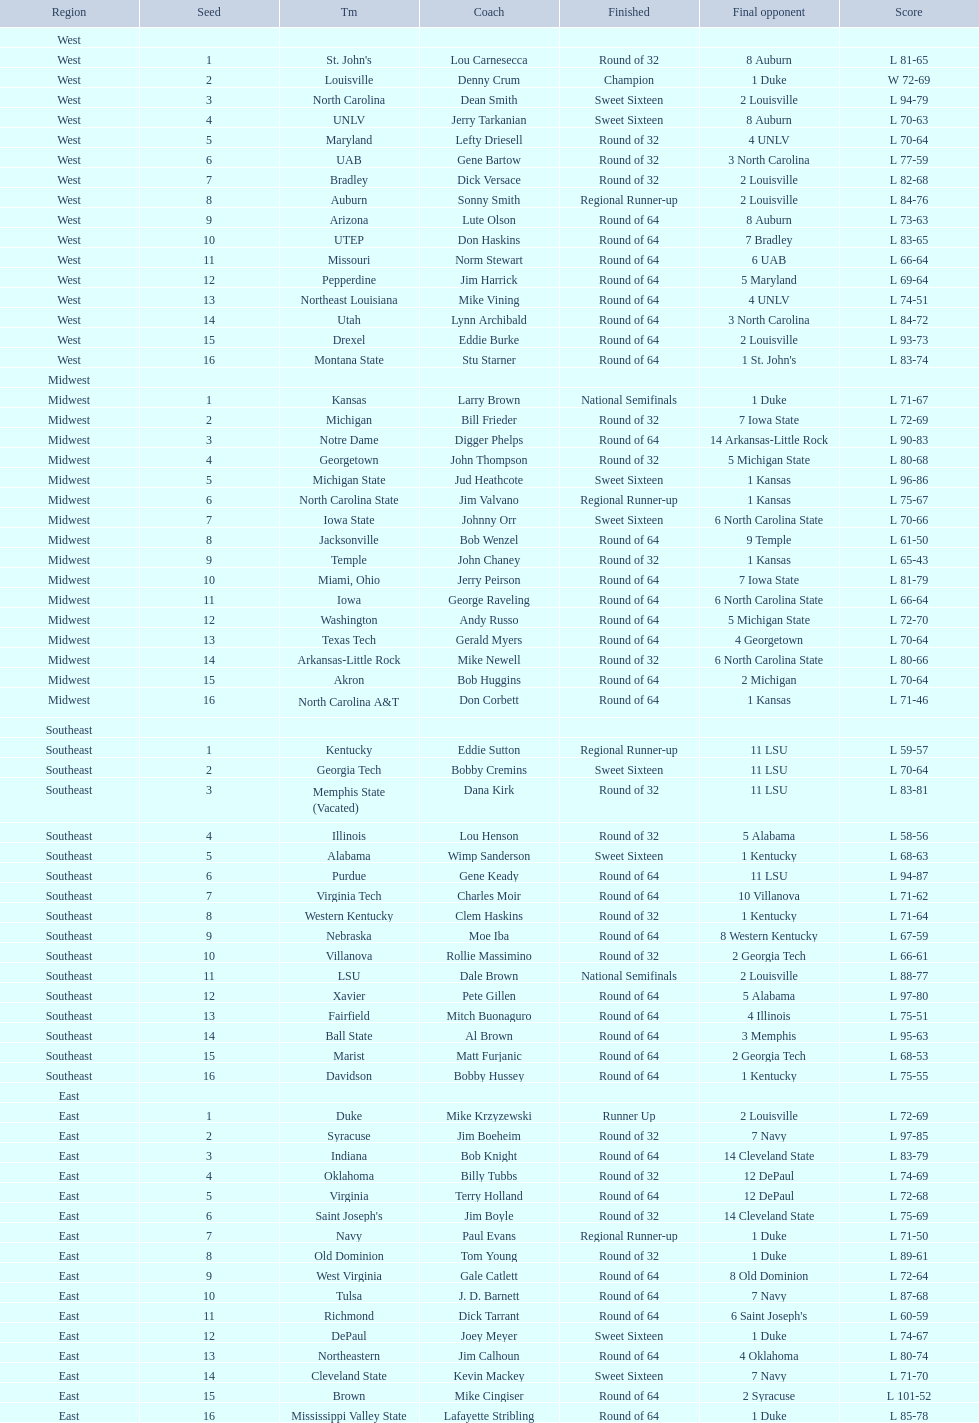Could you parse the entire table as a dict? {'header': ['Region', 'Seed', 'Tm', 'Coach', 'Finished', 'Final opponent', 'Score'], 'rows': [['West', '', '', '', '', '', ''], ['West', '1', "St. John's", 'Lou Carnesecca', 'Round of 32', '8 Auburn', 'L 81-65'], ['West', '2', 'Louisville', 'Denny Crum', 'Champion', '1 Duke', 'W 72-69'], ['West', '3', 'North Carolina', 'Dean Smith', 'Sweet Sixteen', '2 Louisville', 'L 94-79'], ['West', '4', 'UNLV', 'Jerry Tarkanian', 'Sweet Sixteen', '8 Auburn', 'L 70-63'], ['West', '5', 'Maryland', 'Lefty Driesell', 'Round of 32', '4 UNLV', 'L 70-64'], ['West', '6', 'UAB', 'Gene Bartow', 'Round of 32', '3 North Carolina', 'L 77-59'], ['West', '7', 'Bradley', 'Dick Versace', 'Round of 32', '2 Louisville', 'L 82-68'], ['West', '8', 'Auburn', 'Sonny Smith', 'Regional Runner-up', '2 Louisville', 'L 84-76'], ['West', '9', 'Arizona', 'Lute Olson', 'Round of 64', '8 Auburn', 'L 73-63'], ['West', '10', 'UTEP', 'Don Haskins', 'Round of 64', '7 Bradley', 'L 83-65'], ['West', '11', 'Missouri', 'Norm Stewart', 'Round of 64', '6 UAB', 'L 66-64'], ['West', '12', 'Pepperdine', 'Jim Harrick', 'Round of 64', '5 Maryland', 'L 69-64'], ['West', '13', 'Northeast Louisiana', 'Mike Vining', 'Round of 64', '4 UNLV', 'L 74-51'], ['West', '14', 'Utah', 'Lynn Archibald', 'Round of 64', '3 North Carolina', 'L 84-72'], ['West', '15', 'Drexel', 'Eddie Burke', 'Round of 64', '2 Louisville', 'L 93-73'], ['West', '16', 'Montana State', 'Stu Starner', 'Round of 64', "1 St. John's", 'L 83-74'], ['Midwest', '', '', '', '', '', ''], ['Midwest', '1', 'Kansas', 'Larry Brown', 'National Semifinals', '1 Duke', 'L 71-67'], ['Midwest', '2', 'Michigan', 'Bill Frieder', 'Round of 32', '7 Iowa State', 'L 72-69'], ['Midwest', '3', 'Notre Dame', 'Digger Phelps', 'Round of 64', '14 Arkansas-Little Rock', 'L 90-83'], ['Midwest', '4', 'Georgetown', 'John Thompson', 'Round of 32', '5 Michigan State', 'L 80-68'], ['Midwest', '5', 'Michigan State', 'Jud Heathcote', 'Sweet Sixteen', '1 Kansas', 'L 96-86'], ['Midwest', '6', 'North Carolina State', 'Jim Valvano', 'Regional Runner-up', '1 Kansas', 'L 75-67'], ['Midwest', '7', 'Iowa State', 'Johnny Orr', 'Sweet Sixteen', '6 North Carolina State', 'L 70-66'], ['Midwest', '8', 'Jacksonville', 'Bob Wenzel', 'Round of 64', '9 Temple', 'L 61-50'], ['Midwest', '9', 'Temple', 'John Chaney', 'Round of 32', '1 Kansas', 'L 65-43'], ['Midwest', '10', 'Miami, Ohio', 'Jerry Peirson', 'Round of 64', '7 Iowa State', 'L 81-79'], ['Midwest', '11', 'Iowa', 'George Raveling', 'Round of 64', '6 North Carolina State', 'L 66-64'], ['Midwest', '12', 'Washington', 'Andy Russo', 'Round of 64', '5 Michigan State', 'L 72-70'], ['Midwest', '13', 'Texas Tech', 'Gerald Myers', 'Round of 64', '4 Georgetown', 'L 70-64'], ['Midwest', '14', 'Arkansas-Little Rock', 'Mike Newell', 'Round of 32', '6 North Carolina State', 'L 80-66'], ['Midwest', '15', 'Akron', 'Bob Huggins', 'Round of 64', '2 Michigan', 'L 70-64'], ['Midwest', '16', 'North Carolina A&T', 'Don Corbett', 'Round of 64', '1 Kansas', 'L 71-46'], ['Southeast', '', '', '', '', '', ''], ['Southeast', '1', 'Kentucky', 'Eddie Sutton', 'Regional Runner-up', '11 LSU', 'L 59-57'], ['Southeast', '2', 'Georgia Tech', 'Bobby Cremins', 'Sweet Sixteen', '11 LSU', 'L 70-64'], ['Southeast', '3', 'Memphis State (Vacated)', 'Dana Kirk', 'Round of 32', '11 LSU', 'L 83-81'], ['Southeast', '4', 'Illinois', 'Lou Henson', 'Round of 32', '5 Alabama', 'L 58-56'], ['Southeast', '5', 'Alabama', 'Wimp Sanderson', 'Sweet Sixteen', '1 Kentucky', 'L 68-63'], ['Southeast', '6', 'Purdue', 'Gene Keady', 'Round of 64', '11 LSU', 'L 94-87'], ['Southeast', '7', 'Virginia Tech', 'Charles Moir', 'Round of 64', '10 Villanova', 'L 71-62'], ['Southeast', '8', 'Western Kentucky', 'Clem Haskins', 'Round of 32', '1 Kentucky', 'L 71-64'], ['Southeast', '9', 'Nebraska', 'Moe Iba', 'Round of 64', '8 Western Kentucky', 'L 67-59'], ['Southeast', '10', 'Villanova', 'Rollie Massimino', 'Round of 32', '2 Georgia Tech', 'L 66-61'], ['Southeast', '11', 'LSU', 'Dale Brown', 'National Semifinals', '2 Louisville', 'L 88-77'], ['Southeast', '12', 'Xavier', 'Pete Gillen', 'Round of 64', '5 Alabama', 'L 97-80'], ['Southeast', '13', 'Fairfield', 'Mitch Buonaguro', 'Round of 64', '4 Illinois', 'L 75-51'], ['Southeast', '14', 'Ball State', 'Al Brown', 'Round of 64', '3 Memphis', 'L 95-63'], ['Southeast', '15', 'Marist', 'Matt Furjanic', 'Round of 64', '2 Georgia Tech', 'L 68-53'], ['Southeast', '16', 'Davidson', 'Bobby Hussey', 'Round of 64', '1 Kentucky', 'L 75-55'], ['East', '', '', '', '', '', ''], ['East', '1', 'Duke', 'Mike Krzyzewski', 'Runner Up', '2 Louisville', 'L 72-69'], ['East', '2', 'Syracuse', 'Jim Boeheim', 'Round of 32', '7 Navy', 'L 97-85'], ['East', '3', 'Indiana', 'Bob Knight', 'Round of 64', '14 Cleveland State', 'L 83-79'], ['East', '4', 'Oklahoma', 'Billy Tubbs', 'Round of 32', '12 DePaul', 'L 74-69'], ['East', '5', 'Virginia', 'Terry Holland', 'Round of 64', '12 DePaul', 'L 72-68'], ['East', '6', "Saint Joseph's", 'Jim Boyle', 'Round of 32', '14 Cleveland State', 'L 75-69'], ['East', '7', 'Navy', 'Paul Evans', 'Regional Runner-up', '1 Duke', 'L 71-50'], ['East', '8', 'Old Dominion', 'Tom Young', 'Round of 32', '1 Duke', 'L 89-61'], ['East', '9', 'West Virginia', 'Gale Catlett', 'Round of 64', '8 Old Dominion', 'L 72-64'], ['East', '10', 'Tulsa', 'J. D. Barnett', 'Round of 64', '7 Navy', 'L 87-68'], ['East', '11', 'Richmond', 'Dick Tarrant', 'Round of 64', "6 Saint Joseph's", 'L 60-59'], ['East', '12', 'DePaul', 'Joey Meyer', 'Sweet Sixteen', '1 Duke', 'L 74-67'], ['East', '13', 'Northeastern', 'Jim Calhoun', 'Round of 64', '4 Oklahoma', 'L 80-74'], ['East', '14', 'Cleveland State', 'Kevin Mackey', 'Sweet Sixteen', '7 Navy', 'L 71-70'], ['East', '15', 'Brown', 'Mike Cingiser', 'Round of 64', '2 Syracuse', 'L 101-52'], ['East', '16', 'Mississippi Valley State', 'Lafayette Stribling', 'Round of 64', '1 Duke', 'L 85-78']]} North carolina and unlv each made it to which round? Sweet Sixteen. 